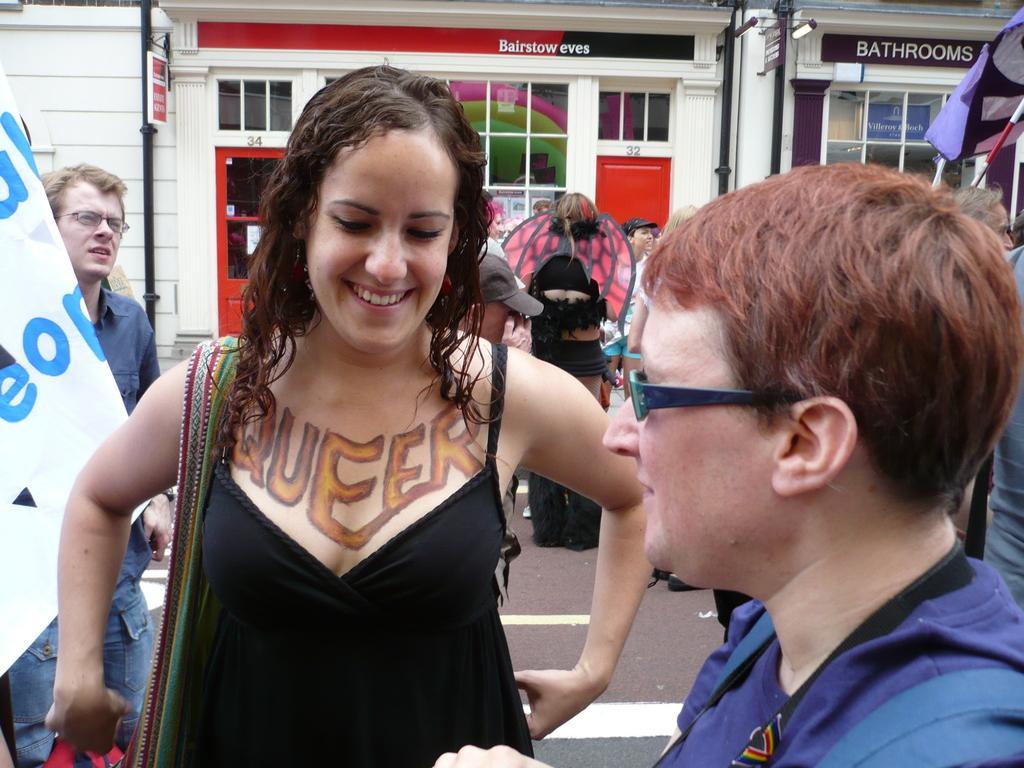Could you give a brief overview of what you see in this image? In this image, we can see a lady smiling and there are some other people. Some of them are holding flags. In the background, there are buildings. 